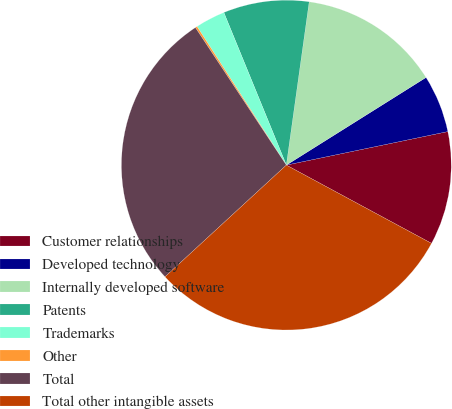<chart> <loc_0><loc_0><loc_500><loc_500><pie_chart><fcel>Customer relationships<fcel>Developed technology<fcel>Internally developed software<fcel>Patents<fcel>Trademarks<fcel>Other<fcel>Total<fcel>Total other intangible assets<nl><fcel>11.13%<fcel>5.66%<fcel>13.87%<fcel>8.4%<fcel>2.92%<fcel>0.19%<fcel>27.55%<fcel>30.29%<nl></chart> 